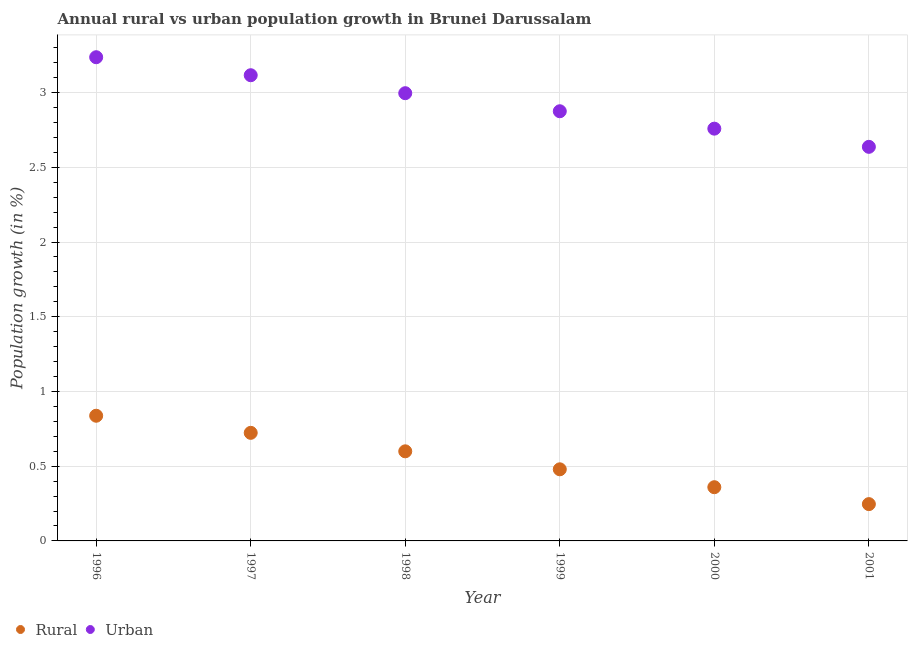How many different coloured dotlines are there?
Provide a short and direct response. 2. Is the number of dotlines equal to the number of legend labels?
Your answer should be very brief. Yes. What is the rural population growth in 1998?
Provide a short and direct response. 0.6. Across all years, what is the maximum urban population growth?
Your answer should be compact. 3.24. Across all years, what is the minimum rural population growth?
Keep it short and to the point. 0.25. In which year was the urban population growth minimum?
Your response must be concise. 2001. What is the total rural population growth in the graph?
Your answer should be very brief. 3.25. What is the difference between the urban population growth in 1996 and that in 1997?
Ensure brevity in your answer.  0.12. What is the difference between the rural population growth in 2001 and the urban population growth in 1999?
Offer a very short reply. -2.63. What is the average rural population growth per year?
Provide a succinct answer. 0.54. In the year 1998, what is the difference between the urban population growth and rural population growth?
Make the answer very short. 2.4. What is the ratio of the urban population growth in 1996 to that in 2001?
Make the answer very short. 1.23. Is the difference between the urban population growth in 1999 and 2000 greater than the difference between the rural population growth in 1999 and 2000?
Give a very brief answer. No. What is the difference between the highest and the second highest rural population growth?
Your answer should be compact. 0.11. What is the difference between the highest and the lowest urban population growth?
Provide a succinct answer. 0.6. In how many years, is the urban population growth greater than the average urban population growth taken over all years?
Provide a succinct answer. 3. Is the sum of the urban population growth in 2000 and 2001 greater than the maximum rural population growth across all years?
Offer a terse response. Yes. Is the rural population growth strictly less than the urban population growth over the years?
Make the answer very short. Yes. What is the difference between two consecutive major ticks on the Y-axis?
Your response must be concise. 0.5. Are the values on the major ticks of Y-axis written in scientific E-notation?
Give a very brief answer. No. Does the graph contain any zero values?
Your response must be concise. No. Does the graph contain grids?
Provide a short and direct response. Yes. How are the legend labels stacked?
Provide a succinct answer. Horizontal. What is the title of the graph?
Offer a very short reply. Annual rural vs urban population growth in Brunei Darussalam. Does "Secondary school" appear as one of the legend labels in the graph?
Offer a terse response. No. What is the label or title of the Y-axis?
Provide a short and direct response. Population growth (in %). What is the Population growth (in %) of Rural in 1996?
Your answer should be compact. 0.84. What is the Population growth (in %) in Urban  in 1996?
Offer a terse response. 3.24. What is the Population growth (in %) of Rural in 1997?
Offer a very short reply. 0.72. What is the Population growth (in %) in Urban  in 1997?
Keep it short and to the point. 3.12. What is the Population growth (in %) in Rural in 1998?
Offer a terse response. 0.6. What is the Population growth (in %) in Urban  in 1998?
Offer a terse response. 3. What is the Population growth (in %) of Rural in 1999?
Your answer should be compact. 0.48. What is the Population growth (in %) of Urban  in 1999?
Give a very brief answer. 2.87. What is the Population growth (in %) in Rural in 2000?
Offer a very short reply. 0.36. What is the Population growth (in %) in Urban  in 2000?
Your response must be concise. 2.76. What is the Population growth (in %) in Rural in 2001?
Provide a short and direct response. 0.25. What is the Population growth (in %) in Urban  in 2001?
Offer a very short reply. 2.64. Across all years, what is the maximum Population growth (in %) of Rural?
Give a very brief answer. 0.84. Across all years, what is the maximum Population growth (in %) in Urban ?
Keep it short and to the point. 3.24. Across all years, what is the minimum Population growth (in %) of Rural?
Make the answer very short. 0.25. Across all years, what is the minimum Population growth (in %) of Urban ?
Offer a terse response. 2.64. What is the total Population growth (in %) of Rural in the graph?
Give a very brief answer. 3.25. What is the total Population growth (in %) of Urban  in the graph?
Ensure brevity in your answer.  17.62. What is the difference between the Population growth (in %) of Rural in 1996 and that in 1997?
Offer a very short reply. 0.11. What is the difference between the Population growth (in %) in Urban  in 1996 and that in 1997?
Your answer should be very brief. 0.12. What is the difference between the Population growth (in %) of Rural in 1996 and that in 1998?
Your response must be concise. 0.24. What is the difference between the Population growth (in %) of Urban  in 1996 and that in 1998?
Your answer should be compact. 0.24. What is the difference between the Population growth (in %) of Rural in 1996 and that in 1999?
Offer a terse response. 0.36. What is the difference between the Population growth (in %) in Urban  in 1996 and that in 1999?
Your answer should be compact. 0.36. What is the difference between the Population growth (in %) of Rural in 1996 and that in 2000?
Provide a succinct answer. 0.48. What is the difference between the Population growth (in %) in Urban  in 1996 and that in 2000?
Offer a terse response. 0.48. What is the difference between the Population growth (in %) in Rural in 1996 and that in 2001?
Provide a succinct answer. 0.59. What is the difference between the Population growth (in %) in Urban  in 1996 and that in 2001?
Provide a short and direct response. 0.6. What is the difference between the Population growth (in %) in Rural in 1997 and that in 1998?
Provide a succinct answer. 0.12. What is the difference between the Population growth (in %) of Urban  in 1997 and that in 1998?
Your answer should be compact. 0.12. What is the difference between the Population growth (in %) of Rural in 1997 and that in 1999?
Provide a succinct answer. 0.24. What is the difference between the Population growth (in %) in Urban  in 1997 and that in 1999?
Ensure brevity in your answer.  0.24. What is the difference between the Population growth (in %) in Rural in 1997 and that in 2000?
Give a very brief answer. 0.36. What is the difference between the Population growth (in %) of Urban  in 1997 and that in 2000?
Keep it short and to the point. 0.36. What is the difference between the Population growth (in %) of Rural in 1997 and that in 2001?
Offer a very short reply. 0.48. What is the difference between the Population growth (in %) in Urban  in 1997 and that in 2001?
Your response must be concise. 0.48. What is the difference between the Population growth (in %) of Rural in 1998 and that in 1999?
Make the answer very short. 0.12. What is the difference between the Population growth (in %) in Urban  in 1998 and that in 1999?
Your answer should be very brief. 0.12. What is the difference between the Population growth (in %) of Rural in 1998 and that in 2000?
Ensure brevity in your answer.  0.24. What is the difference between the Population growth (in %) in Urban  in 1998 and that in 2000?
Offer a terse response. 0.24. What is the difference between the Population growth (in %) of Rural in 1998 and that in 2001?
Make the answer very short. 0.35. What is the difference between the Population growth (in %) of Urban  in 1998 and that in 2001?
Give a very brief answer. 0.36. What is the difference between the Population growth (in %) in Rural in 1999 and that in 2000?
Your answer should be very brief. 0.12. What is the difference between the Population growth (in %) in Urban  in 1999 and that in 2000?
Make the answer very short. 0.12. What is the difference between the Population growth (in %) in Rural in 1999 and that in 2001?
Ensure brevity in your answer.  0.23. What is the difference between the Population growth (in %) of Urban  in 1999 and that in 2001?
Offer a terse response. 0.24. What is the difference between the Population growth (in %) in Rural in 2000 and that in 2001?
Your answer should be very brief. 0.11. What is the difference between the Population growth (in %) in Urban  in 2000 and that in 2001?
Your answer should be compact. 0.12. What is the difference between the Population growth (in %) of Rural in 1996 and the Population growth (in %) of Urban  in 1997?
Provide a short and direct response. -2.28. What is the difference between the Population growth (in %) in Rural in 1996 and the Population growth (in %) in Urban  in 1998?
Provide a short and direct response. -2.16. What is the difference between the Population growth (in %) in Rural in 1996 and the Population growth (in %) in Urban  in 1999?
Make the answer very short. -2.04. What is the difference between the Population growth (in %) in Rural in 1996 and the Population growth (in %) in Urban  in 2000?
Your answer should be very brief. -1.92. What is the difference between the Population growth (in %) of Rural in 1996 and the Population growth (in %) of Urban  in 2001?
Your response must be concise. -1.8. What is the difference between the Population growth (in %) of Rural in 1997 and the Population growth (in %) of Urban  in 1998?
Provide a succinct answer. -2.27. What is the difference between the Population growth (in %) in Rural in 1997 and the Population growth (in %) in Urban  in 1999?
Your answer should be compact. -2.15. What is the difference between the Population growth (in %) in Rural in 1997 and the Population growth (in %) in Urban  in 2000?
Offer a very short reply. -2.04. What is the difference between the Population growth (in %) in Rural in 1997 and the Population growth (in %) in Urban  in 2001?
Make the answer very short. -1.91. What is the difference between the Population growth (in %) in Rural in 1998 and the Population growth (in %) in Urban  in 1999?
Provide a succinct answer. -2.28. What is the difference between the Population growth (in %) of Rural in 1998 and the Population growth (in %) of Urban  in 2000?
Your answer should be very brief. -2.16. What is the difference between the Population growth (in %) of Rural in 1998 and the Population growth (in %) of Urban  in 2001?
Give a very brief answer. -2.04. What is the difference between the Population growth (in %) of Rural in 1999 and the Population growth (in %) of Urban  in 2000?
Provide a succinct answer. -2.28. What is the difference between the Population growth (in %) of Rural in 1999 and the Population growth (in %) of Urban  in 2001?
Your answer should be compact. -2.16. What is the difference between the Population growth (in %) in Rural in 2000 and the Population growth (in %) in Urban  in 2001?
Make the answer very short. -2.28. What is the average Population growth (in %) of Rural per year?
Provide a short and direct response. 0.54. What is the average Population growth (in %) of Urban  per year?
Your answer should be compact. 2.94. In the year 1996, what is the difference between the Population growth (in %) in Rural and Population growth (in %) in Urban ?
Your response must be concise. -2.4. In the year 1997, what is the difference between the Population growth (in %) of Rural and Population growth (in %) of Urban ?
Offer a very short reply. -2.39. In the year 1998, what is the difference between the Population growth (in %) of Rural and Population growth (in %) of Urban ?
Your answer should be compact. -2.4. In the year 1999, what is the difference between the Population growth (in %) of Rural and Population growth (in %) of Urban ?
Keep it short and to the point. -2.4. In the year 2000, what is the difference between the Population growth (in %) in Rural and Population growth (in %) in Urban ?
Provide a short and direct response. -2.4. In the year 2001, what is the difference between the Population growth (in %) of Rural and Population growth (in %) of Urban ?
Your response must be concise. -2.39. What is the ratio of the Population growth (in %) of Rural in 1996 to that in 1997?
Your answer should be very brief. 1.16. What is the ratio of the Population growth (in %) in Urban  in 1996 to that in 1997?
Give a very brief answer. 1.04. What is the ratio of the Population growth (in %) in Rural in 1996 to that in 1998?
Give a very brief answer. 1.4. What is the ratio of the Population growth (in %) in Urban  in 1996 to that in 1998?
Make the answer very short. 1.08. What is the ratio of the Population growth (in %) in Rural in 1996 to that in 1999?
Keep it short and to the point. 1.75. What is the ratio of the Population growth (in %) of Urban  in 1996 to that in 1999?
Offer a terse response. 1.13. What is the ratio of the Population growth (in %) of Rural in 1996 to that in 2000?
Offer a terse response. 2.33. What is the ratio of the Population growth (in %) of Urban  in 1996 to that in 2000?
Your answer should be very brief. 1.17. What is the ratio of the Population growth (in %) in Rural in 1996 to that in 2001?
Keep it short and to the point. 3.4. What is the ratio of the Population growth (in %) of Urban  in 1996 to that in 2001?
Your response must be concise. 1.23. What is the ratio of the Population growth (in %) of Rural in 1997 to that in 1998?
Give a very brief answer. 1.21. What is the ratio of the Population growth (in %) of Urban  in 1997 to that in 1998?
Offer a terse response. 1.04. What is the ratio of the Population growth (in %) of Rural in 1997 to that in 1999?
Ensure brevity in your answer.  1.51. What is the ratio of the Population growth (in %) of Urban  in 1997 to that in 1999?
Your response must be concise. 1.08. What is the ratio of the Population growth (in %) in Rural in 1997 to that in 2000?
Provide a short and direct response. 2.01. What is the ratio of the Population growth (in %) in Urban  in 1997 to that in 2000?
Keep it short and to the point. 1.13. What is the ratio of the Population growth (in %) in Rural in 1997 to that in 2001?
Provide a succinct answer. 2.94. What is the ratio of the Population growth (in %) in Urban  in 1997 to that in 2001?
Ensure brevity in your answer.  1.18. What is the ratio of the Population growth (in %) of Rural in 1998 to that in 1999?
Offer a terse response. 1.25. What is the ratio of the Population growth (in %) of Urban  in 1998 to that in 1999?
Keep it short and to the point. 1.04. What is the ratio of the Population growth (in %) of Rural in 1998 to that in 2000?
Ensure brevity in your answer.  1.67. What is the ratio of the Population growth (in %) of Urban  in 1998 to that in 2000?
Offer a very short reply. 1.09. What is the ratio of the Population growth (in %) in Rural in 1998 to that in 2001?
Provide a short and direct response. 2.43. What is the ratio of the Population growth (in %) of Urban  in 1998 to that in 2001?
Your response must be concise. 1.14. What is the ratio of the Population growth (in %) of Rural in 1999 to that in 2000?
Your answer should be compact. 1.33. What is the ratio of the Population growth (in %) of Urban  in 1999 to that in 2000?
Ensure brevity in your answer.  1.04. What is the ratio of the Population growth (in %) in Rural in 1999 to that in 2001?
Offer a terse response. 1.95. What is the ratio of the Population growth (in %) of Urban  in 1999 to that in 2001?
Your response must be concise. 1.09. What is the ratio of the Population growth (in %) of Rural in 2000 to that in 2001?
Offer a terse response. 1.46. What is the ratio of the Population growth (in %) of Urban  in 2000 to that in 2001?
Make the answer very short. 1.05. What is the difference between the highest and the second highest Population growth (in %) of Rural?
Your response must be concise. 0.11. What is the difference between the highest and the second highest Population growth (in %) in Urban ?
Your answer should be compact. 0.12. What is the difference between the highest and the lowest Population growth (in %) in Rural?
Offer a terse response. 0.59. What is the difference between the highest and the lowest Population growth (in %) in Urban ?
Ensure brevity in your answer.  0.6. 